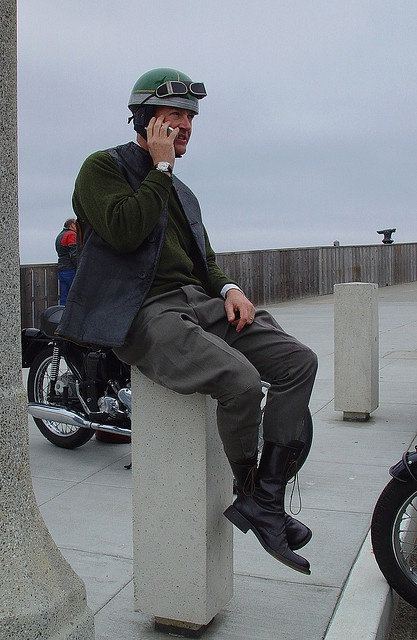Describe the objects in this image and their specific colors. I can see people in gray, black, and darkgray tones, motorcycle in gray, black, darkgray, and purple tones, motorcycle in gray, black, darkgray, and teal tones, people in gray, black, navy, brown, and maroon tones, and cell phone in gray, black, and white tones in this image. 